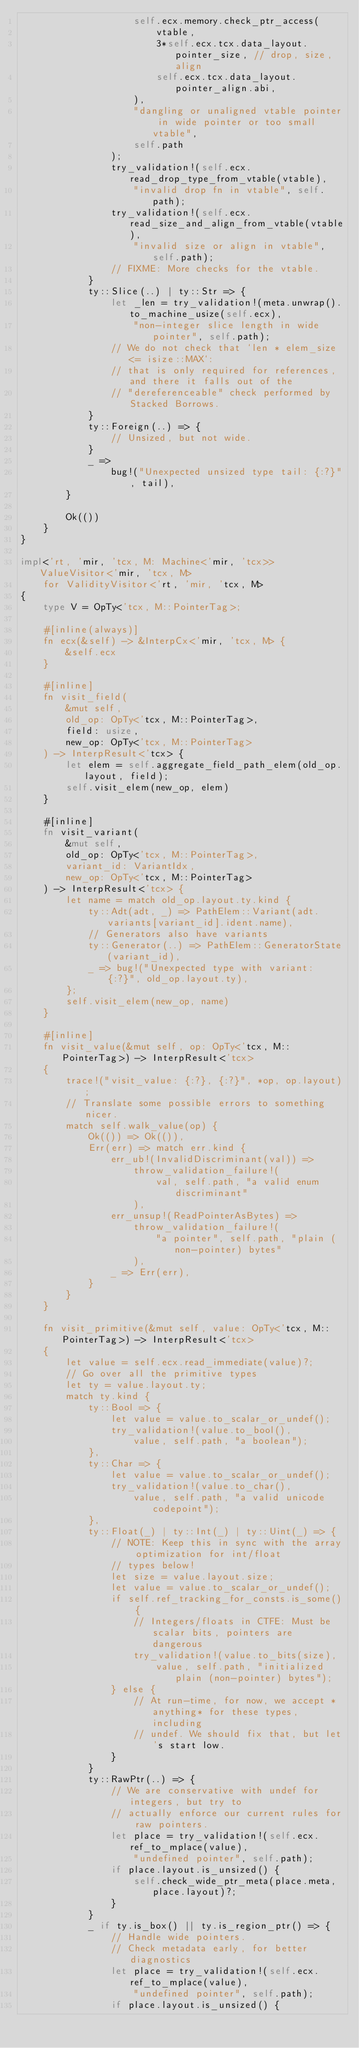Convert code to text. <code><loc_0><loc_0><loc_500><loc_500><_Rust_>                    self.ecx.memory.check_ptr_access(
                        vtable,
                        3*self.ecx.tcx.data_layout.pointer_size, // drop, size, align
                        self.ecx.tcx.data_layout.pointer_align.abi,
                    ),
                    "dangling or unaligned vtable pointer in wide pointer or too small vtable",
                    self.path
                );
                try_validation!(self.ecx.read_drop_type_from_vtable(vtable),
                    "invalid drop fn in vtable", self.path);
                try_validation!(self.ecx.read_size_and_align_from_vtable(vtable),
                    "invalid size or align in vtable", self.path);
                // FIXME: More checks for the vtable.
            }
            ty::Slice(..) | ty::Str => {
                let _len = try_validation!(meta.unwrap().to_machine_usize(self.ecx),
                    "non-integer slice length in wide pointer", self.path);
                // We do not check that `len * elem_size <= isize::MAX`:
                // that is only required for references, and there it falls out of the
                // "dereferenceable" check performed by Stacked Borrows.
            }
            ty::Foreign(..) => {
                // Unsized, but not wide.
            }
            _ =>
                bug!("Unexpected unsized type tail: {:?}", tail),
        }

        Ok(())
    }
}

impl<'rt, 'mir, 'tcx, M: Machine<'mir, 'tcx>> ValueVisitor<'mir, 'tcx, M>
    for ValidityVisitor<'rt, 'mir, 'tcx, M>
{
    type V = OpTy<'tcx, M::PointerTag>;

    #[inline(always)]
    fn ecx(&self) -> &InterpCx<'mir, 'tcx, M> {
        &self.ecx
    }

    #[inline]
    fn visit_field(
        &mut self,
        old_op: OpTy<'tcx, M::PointerTag>,
        field: usize,
        new_op: OpTy<'tcx, M::PointerTag>
    ) -> InterpResult<'tcx> {
        let elem = self.aggregate_field_path_elem(old_op.layout, field);
        self.visit_elem(new_op, elem)
    }

    #[inline]
    fn visit_variant(
        &mut self,
        old_op: OpTy<'tcx, M::PointerTag>,
        variant_id: VariantIdx,
        new_op: OpTy<'tcx, M::PointerTag>
    ) -> InterpResult<'tcx> {
        let name = match old_op.layout.ty.kind {
            ty::Adt(adt, _) => PathElem::Variant(adt.variants[variant_id].ident.name),
            // Generators also have variants
            ty::Generator(..) => PathElem::GeneratorState(variant_id),
            _ => bug!("Unexpected type with variant: {:?}", old_op.layout.ty),
        };
        self.visit_elem(new_op, name)
    }

    #[inline]
    fn visit_value(&mut self, op: OpTy<'tcx, M::PointerTag>) -> InterpResult<'tcx>
    {
        trace!("visit_value: {:?}, {:?}", *op, op.layout);
        // Translate some possible errors to something nicer.
        match self.walk_value(op) {
            Ok(()) => Ok(()),
            Err(err) => match err.kind {
                err_ub!(InvalidDiscriminant(val)) =>
                    throw_validation_failure!(
                        val, self.path, "a valid enum discriminant"
                    ),
                err_unsup!(ReadPointerAsBytes) =>
                    throw_validation_failure!(
                        "a pointer", self.path, "plain (non-pointer) bytes"
                    ),
                _ => Err(err),
            }
        }
    }

    fn visit_primitive(&mut self, value: OpTy<'tcx, M::PointerTag>) -> InterpResult<'tcx>
    {
        let value = self.ecx.read_immediate(value)?;
        // Go over all the primitive types
        let ty = value.layout.ty;
        match ty.kind {
            ty::Bool => {
                let value = value.to_scalar_or_undef();
                try_validation!(value.to_bool(),
                    value, self.path, "a boolean");
            },
            ty::Char => {
                let value = value.to_scalar_or_undef();
                try_validation!(value.to_char(),
                    value, self.path, "a valid unicode codepoint");
            },
            ty::Float(_) | ty::Int(_) | ty::Uint(_) => {
                // NOTE: Keep this in sync with the array optimization for int/float
                // types below!
                let size = value.layout.size;
                let value = value.to_scalar_or_undef();
                if self.ref_tracking_for_consts.is_some() {
                    // Integers/floats in CTFE: Must be scalar bits, pointers are dangerous
                    try_validation!(value.to_bits(size),
                        value, self.path, "initialized plain (non-pointer) bytes");
                } else {
                    // At run-time, for now, we accept *anything* for these types, including
                    // undef. We should fix that, but let's start low.
                }
            }
            ty::RawPtr(..) => {
                // We are conservative with undef for integers, but try to
                // actually enforce our current rules for raw pointers.
                let place = try_validation!(self.ecx.ref_to_mplace(value),
                    "undefined pointer", self.path);
                if place.layout.is_unsized() {
                    self.check_wide_ptr_meta(place.meta, place.layout)?;
                }
            }
            _ if ty.is_box() || ty.is_region_ptr() => {
                // Handle wide pointers.
                // Check metadata early, for better diagnostics
                let place = try_validation!(self.ecx.ref_to_mplace(value),
                    "undefined pointer", self.path);
                if place.layout.is_unsized() {</code> 